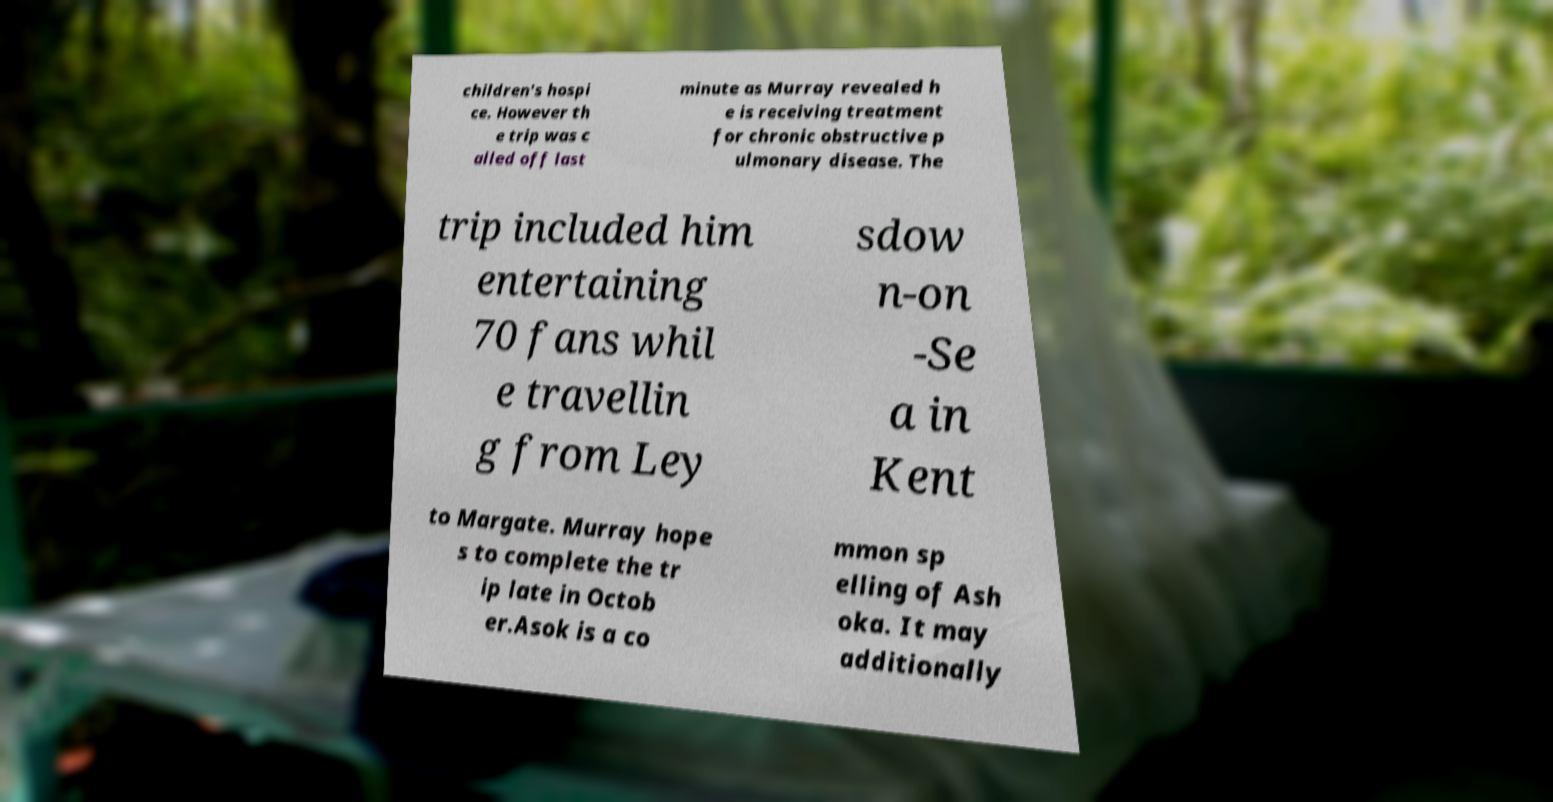There's text embedded in this image that I need extracted. Can you transcribe it verbatim? children's hospi ce. However th e trip was c alled off last minute as Murray revealed h e is receiving treatment for chronic obstructive p ulmonary disease. The trip included him entertaining 70 fans whil e travellin g from Ley sdow n-on -Se a in Kent to Margate. Murray hope s to complete the tr ip late in Octob er.Asok is a co mmon sp elling of Ash oka. It may additionally 